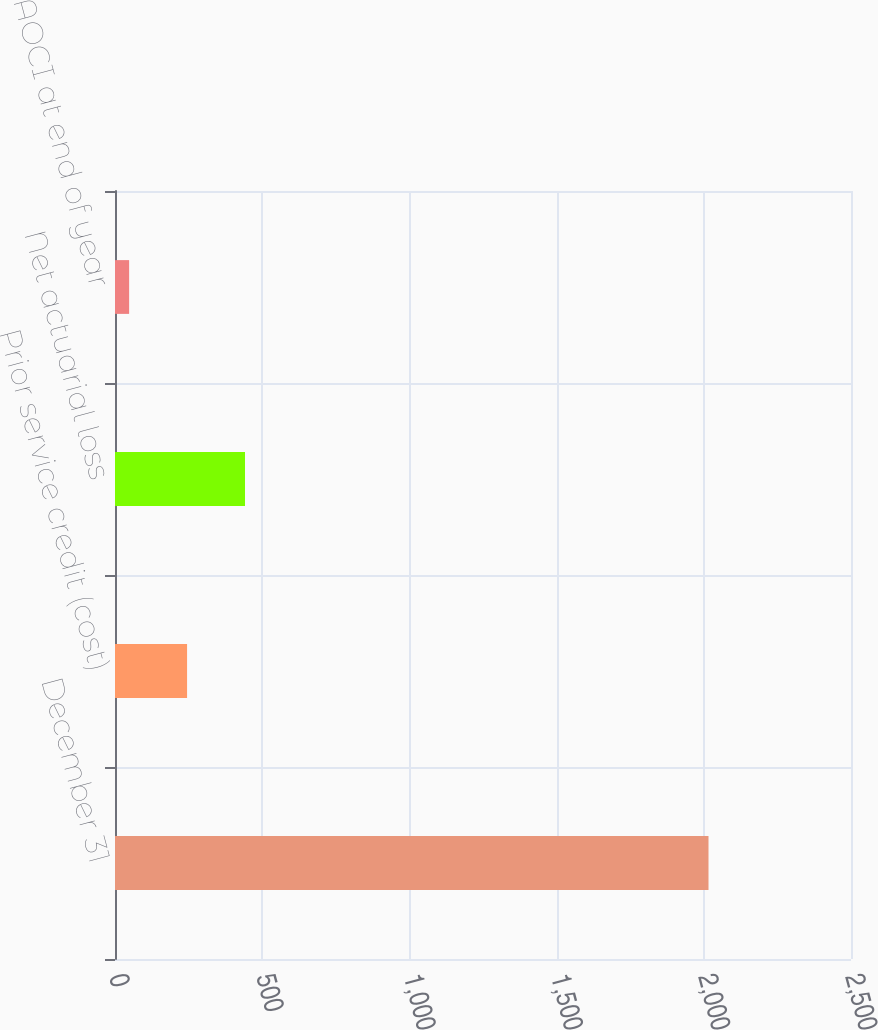Convert chart. <chart><loc_0><loc_0><loc_500><loc_500><bar_chart><fcel>December 31<fcel>Prior service credit (cost)<fcel>Net actuarial loss<fcel>Balance in AOCI at end of year<nl><fcel>2016<fcel>244.8<fcel>441.6<fcel>48<nl></chart> 